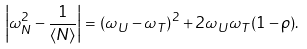<formula> <loc_0><loc_0><loc_500><loc_500>\left | \omega ^ { 2 } _ { N } - \frac { 1 } { \langle N \rangle } \right | = \left ( \omega _ { U } - \omega _ { T } \right ) ^ { 2 } + 2 \omega _ { U } \omega _ { T } ( 1 - \rho ) .</formula> 